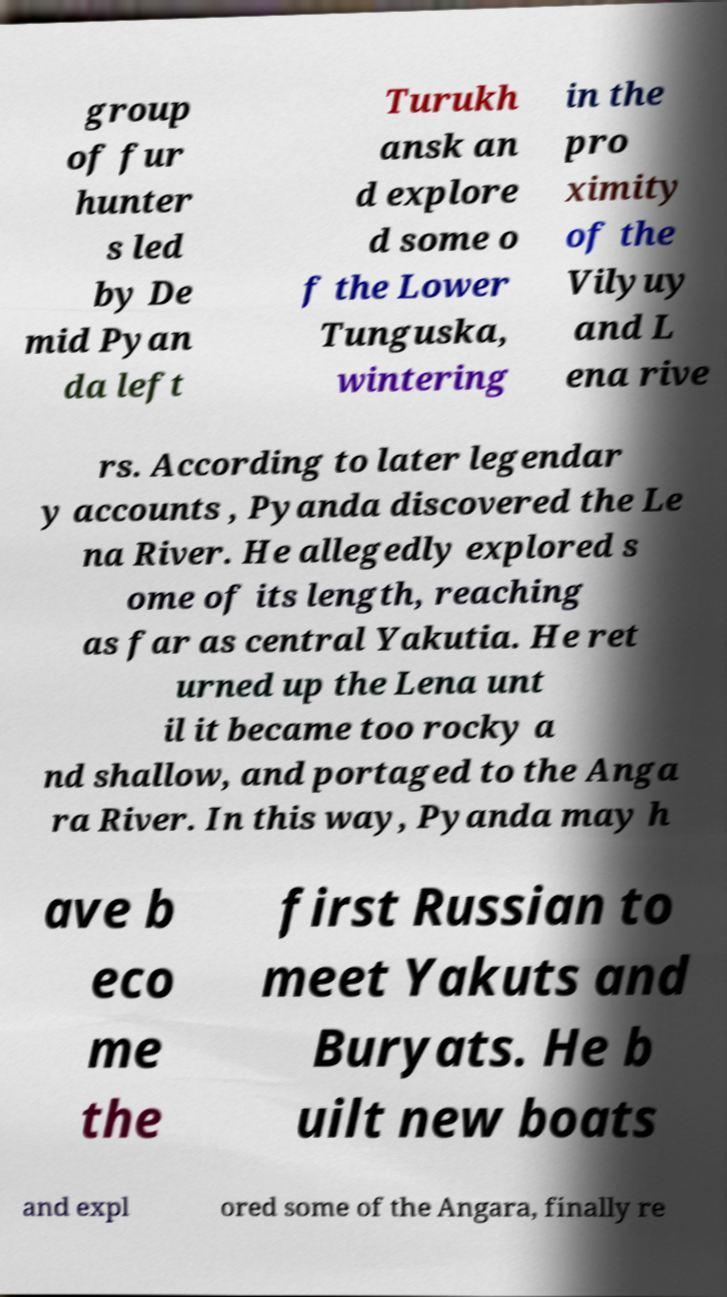I need the written content from this picture converted into text. Can you do that? group of fur hunter s led by De mid Pyan da left Turukh ansk an d explore d some o f the Lower Tunguska, wintering in the pro ximity of the Vilyuy and L ena rive rs. According to later legendar y accounts , Pyanda discovered the Le na River. He allegedly explored s ome of its length, reaching as far as central Yakutia. He ret urned up the Lena unt il it became too rocky a nd shallow, and portaged to the Anga ra River. In this way, Pyanda may h ave b eco me the first Russian to meet Yakuts and Buryats. He b uilt new boats and expl ored some of the Angara, finally re 